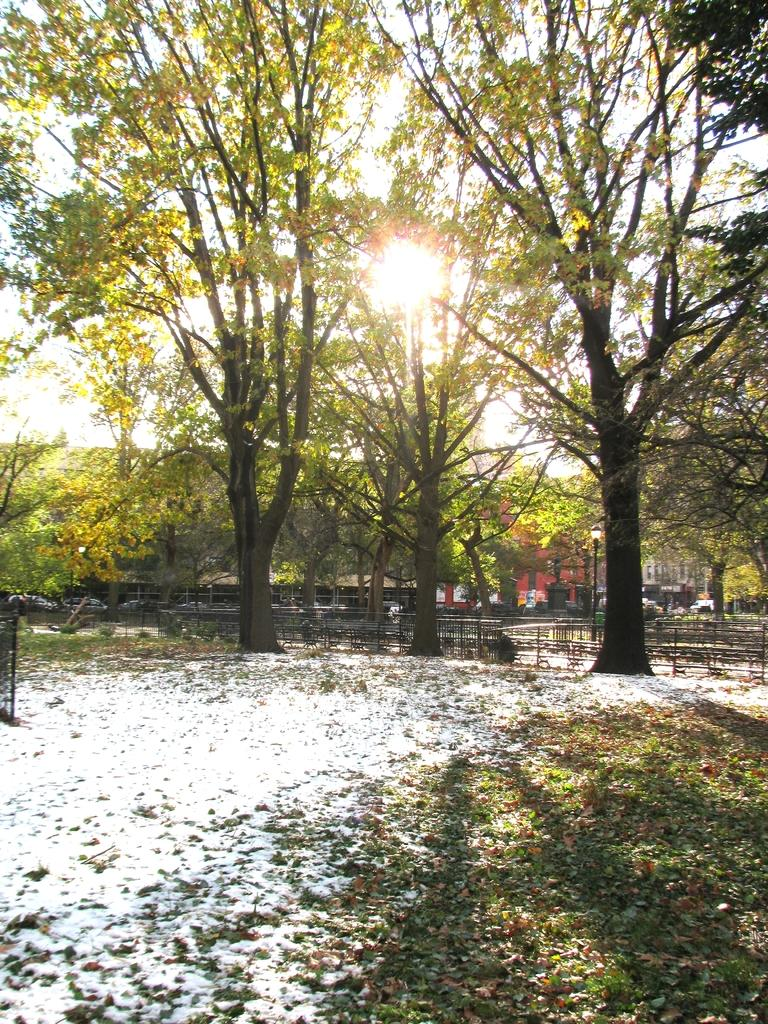What type of natural elements can be seen in the image? There are trees in the image. What man-made structure is present in the image? There is fencing in the image. What part of the natural environment is visible in the image? The sky is visible in the image. Can you describe the background of the image? There appears to be a building behind the trees. What type of suit is the tree wearing in the image? Trees do not wear suits, so this question cannot be answered. 